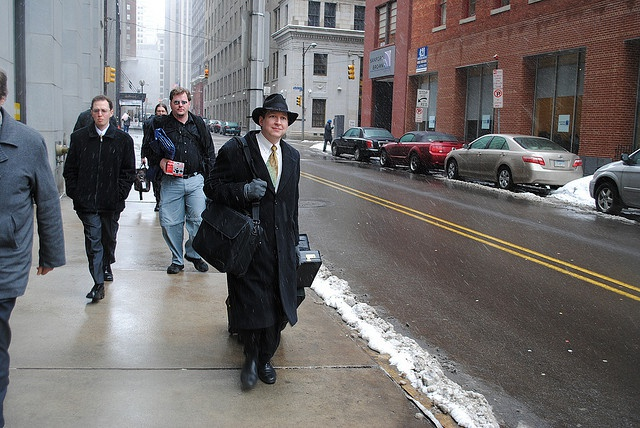Describe the objects in this image and their specific colors. I can see people in darkgray, black, and gray tones, people in darkgray, gray, black, and darkblue tones, people in darkgray, black, gray, and darkblue tones, people in darkgray, black, and gray tones, and car in darkgray, gray, black, and lightgray tones in this image. 